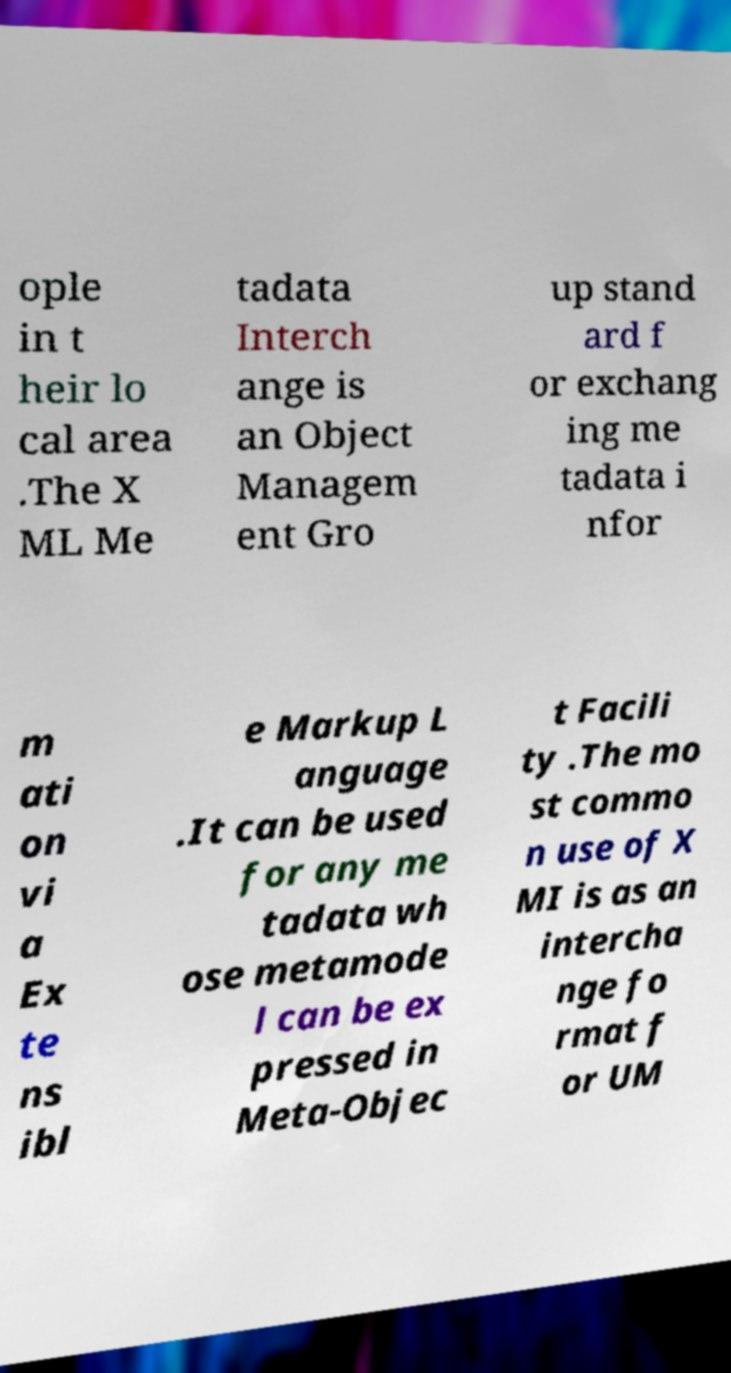Can you accurately transcribe the text from the provided image for me? ople in t heir lo cal area .The X ML Me tadata Interch ange is an Object Managem ent Gro up stand ard f or exchang ing me tadata i nfor m ati on vi a Ex te ns ibl e Markup L anguage .It can be used for any me tadata wh ose metamode l can be ex pressed in Meta-Objec t Facili ty .The mo st commo n use of X MI is as an intercha nge fo rmat f or UM 